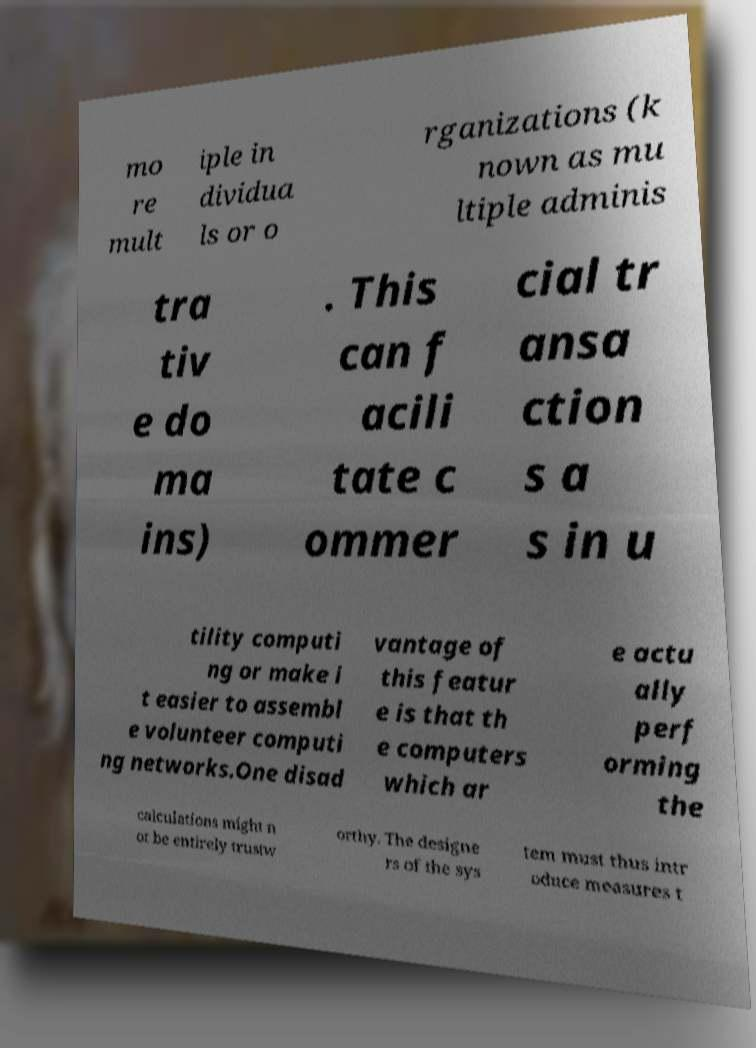Please identify and transcribe the text found in this image. mo re mult iple in dividua ls or o rganizations (k nown as mu ltiple adminis tra tiv e do ma ins) . This can f acili tate c ommer cial tr ansa ction s a s in u tility computi ng or make i t easier to assembl e volunteer computi ng networks.One disad vantage of this featur e is that th e computers which ar e actu ally perf orming the calculations might n ot be entirely trustw orthy. The designe rs of the sys tem must thus intr oduce measures t 